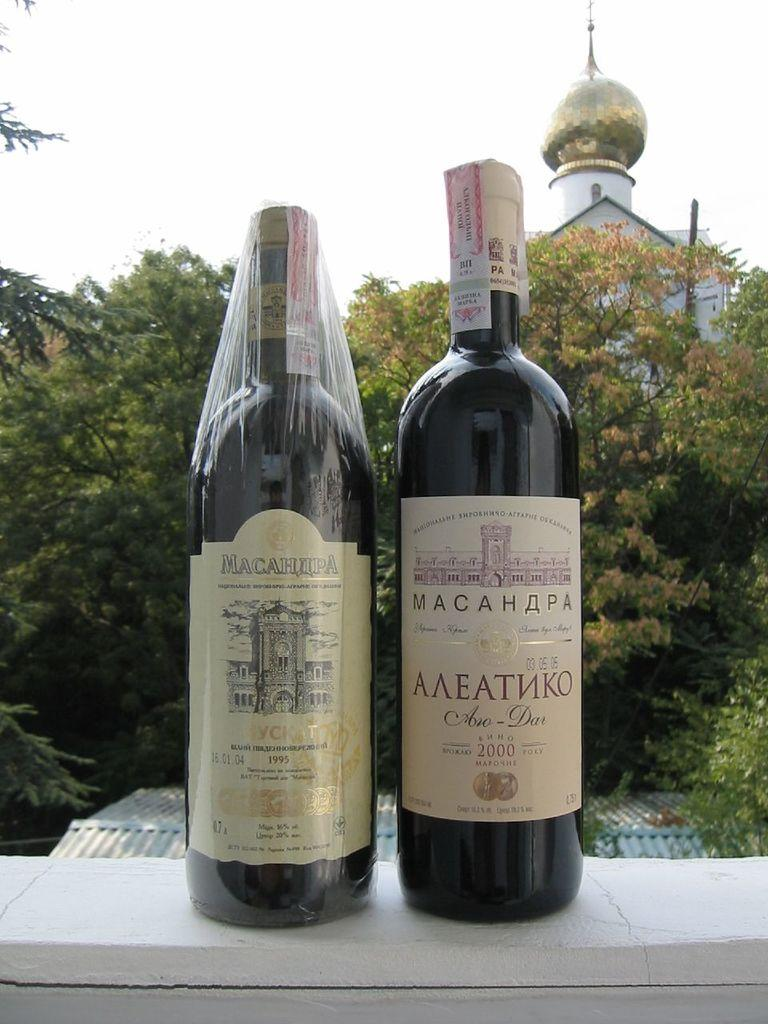Provide a one-sentence caption for the provided image. Two bottles of Russian wine are from the years 1995 and 2000. 